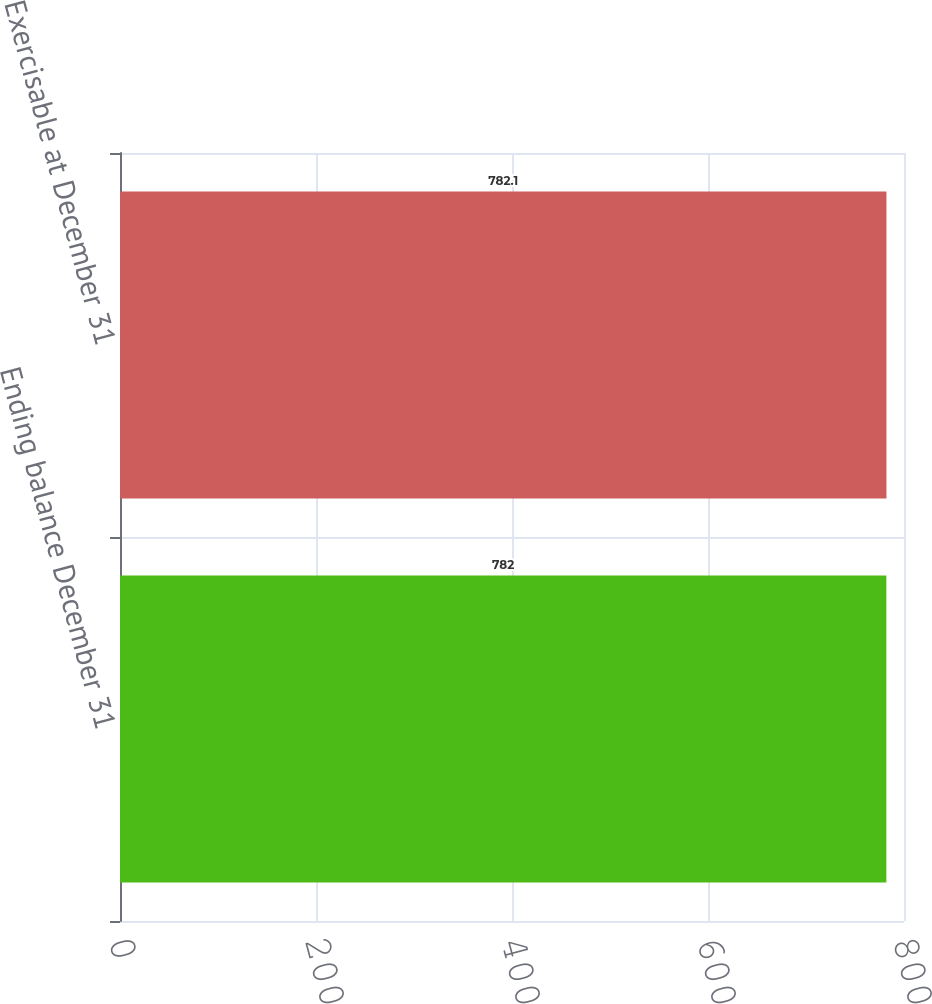Convert chart. <chart><loc_0><loc_0><loc_500><loc_500><bar_chart><fcel>Ending balance December 31<fcel>Exercisable at December 31<nl><fcel>782<fcel>782.1<nl></chart> 